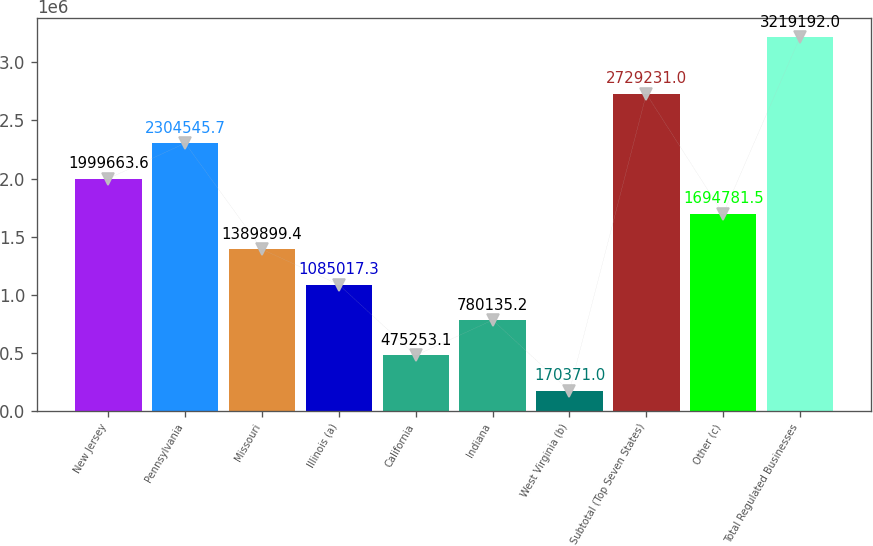<chart> <loc_0><loc_0><loc_500><loc_500><bar_chart><fcel>New Jersey<fcel>Pennsylvania<fcel>Missouri<fcel>Illinois (a)<fcel>California<fcel>Indiana<fcel>West Virginia (b)<fcel>Subtotal (Top Seven States)<fcel>Other (c)<fcel>Total Regulated Businesses<nl><fcel>1.99966e+06<fcel>2.30455e+06<fcel>1.3899e+06<fcel>1.08502e+06<fcel>475253<fcel>780135<fcel>170371<fcel>2.72923e+06<fcel>1.69478e+06<fcel>3.21919e+06<nl></chart> 